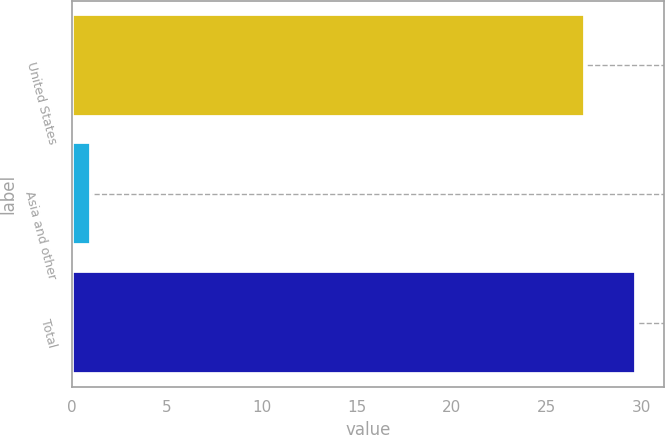Convert chart to OTSL. <chart><loc_0><loc_0><loc_500><loc_500><bar_chart><fcel>United States<fcel>Asia and other<fcel>Total<nl><fcel>27<fcel>1<fcel>29.7<nl></chart> 